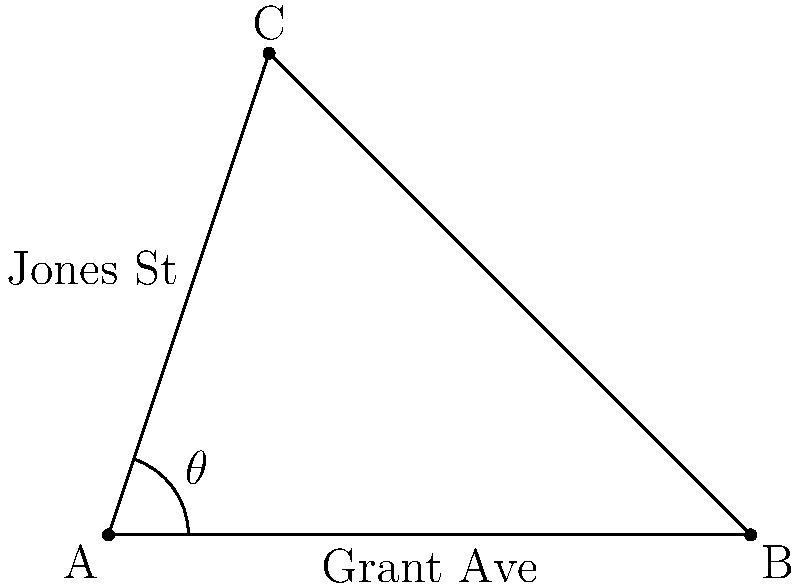In historic downtown Eveleth, Grant Avenue intersects with Jones Street at a point A. If we consider a right-angled triangle formed by these streets and a perpendicular line drawn from point C on Jones Street to Grant Avenue at point B, what is the measure of angle $\theta$ formed between Grant Avenue and Jones Street? Given that AB = 4 blocks, AC = $\sqrt{10}$ blocks, and BC = 3 blocks. Let's approach this step-by-step using the given information and the properties of right-angled triangles:

1) We have a right-angled triangle ABC, where:
   - AB = 4 blocks (along Grant Avenue)
   - BC = 3 blocks (perpendicular to Grant Avenue)
   - AC = $\sqrt{10}$ blocks (along Jones Street)

2) We need to find angle $\theta$, which is the same as angle BAC.

3) In a right-angled triangle, we can use the tangent function to find an angle:

   $\tan \theta = \frac{\text{opposite}}{\text{adjacent}} = \frac{BC}{AB} = \frac{3}{4}$

4) To find $\theta$, we need to use the inverse tangent (arctan) function:

   $\theta = \arctan(\frac{3}{4})$

5) Using a calculator or trigonometric tables, we can find that:

   $\theta \approx 36.87°$

6) To verify, we can use the Pythagorean theorem:
   $AC^2 = AB^2 + BC^2$
   $(\sqrt{10})^2 = 4^2 + 3^2$
   $10 = 16 + 9 = 25$

   This confirms our triangle measurements are correct.

Therefore, the angle between Grant Avenue and Jones Street is approximately 36.87°.
Answer: $36.87°$ 